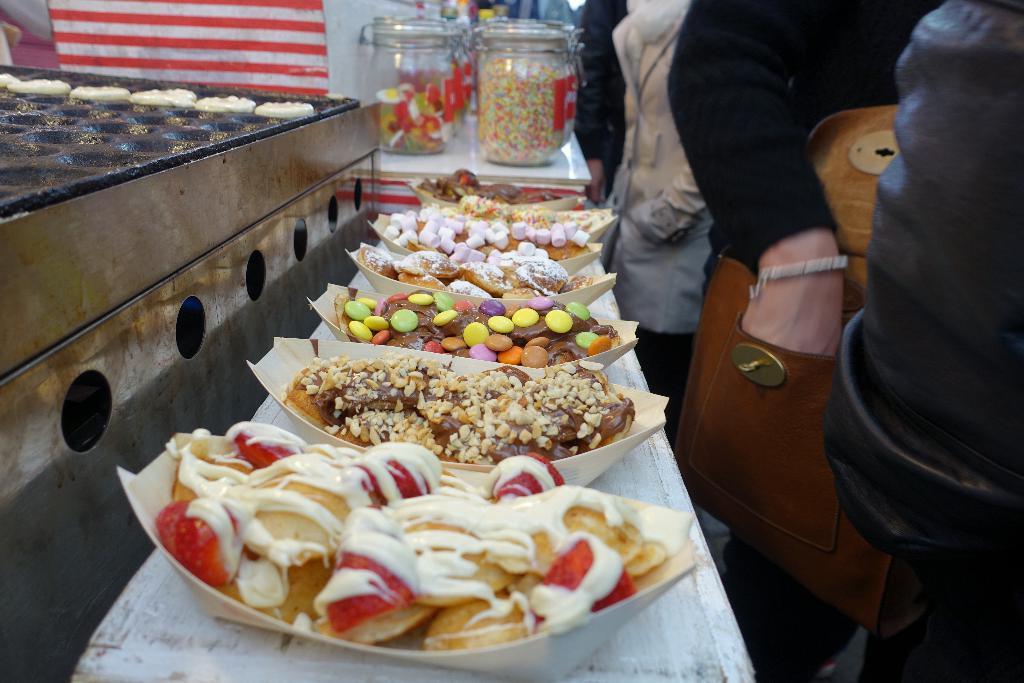Describe this image in one or two sentences. In this image I see number of food items on a table and I see few jars over here and I see number of persons over here and I see the brown color bag and I see the white color things on the black color thing. 